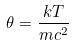<formula> <loc_0><loc_0><loc_500><loc_500>\theta = \frac { k T } { m c ^ { 2 } }</formula> 